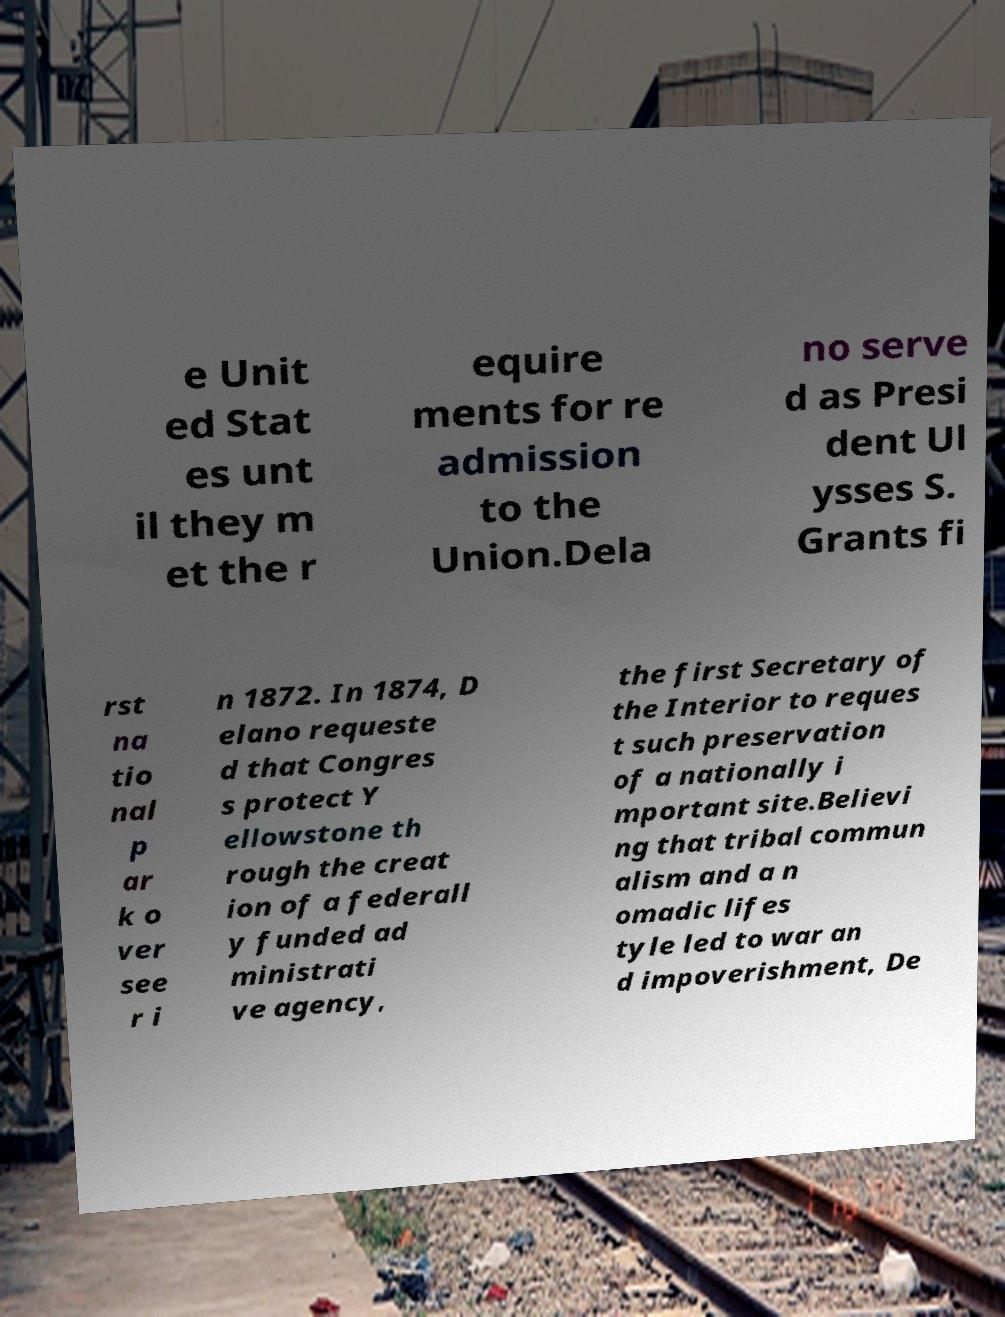What messages or text are displayed in this image? I need them in a readable, typed format. e Unit ed Stat es unt il they m et the r equire ments for re admission to the Union.Dela no serve d as Presi dent Ul ysses S. Grants fi rst na tio nal p ar k o ver see r i n 1872. In 1874, D elano requeste d that Congres s protect Y ellowstone th rough the creat ion of a federall y funded ad ministrati ve agency, the first Secretary of the Interior to reques t such preservation of a nationally i mportant site.Believi ng that tribal commun alism and a n omadic lifes tyle led to war an d impoverishment, De 